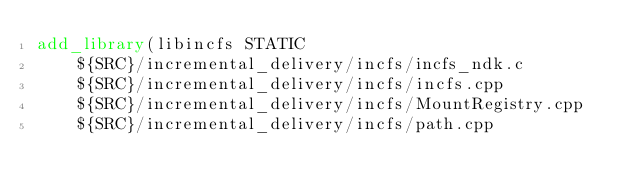<code> <loc_0><loc_0><loc_500><loc_500><_CMake_>add_library(libincfs STATIC
    ${SRC}/incremental_delivery/incfs/incfs_ndk.c
    ${SRC}/incremental_delivery/incfs/incfs.cpp
    ${SRC}/incremental_delivery/incfs/MountRegistry.cpp
    ${SRC}/incremental_delivery/incfs/path.cpp</code> 